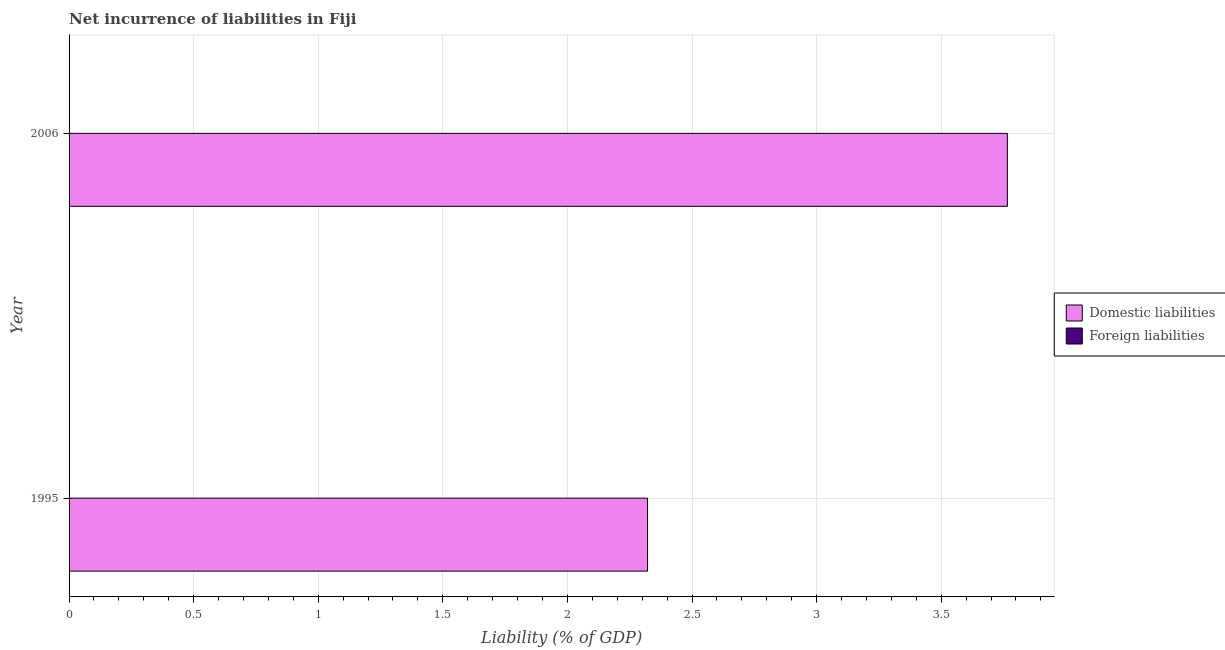Are the number of bars per tick equal to the number of legend labels?
Your answer should be compact. No. How many bars are there on the 2nd tick from the top?
Provide a succinct answer. 1. What is the label of the 1st group of bars from the top?
Your answer should be very brief. 2006. What is the incurrence of foreign liabilities in 2006?
Provide a short and direct response. 0. Across all years, what is the maximum incurrence of domestic liabilities?
Your answer should be very brief. 3.77. In which year was the incurrence of domestic liabilities maximum?
Your answer should be very brief. 2006. What is the difference between the incurrence of domestic liabilities in 1995 and that in 2006?
Keep it short and to the point. -1.44. What is the difference between the incurrence of foreign liabilities in 2006 and the incurrence of domestic liabilities in 1995?
Give a very brief answer. -2.32. What is the average incurrence of domestic liabilities per year?
Keep it short and to the point. 3.04. What is the ratio of the incurrence of domestic liabilities in 1995 to that in 2006?
Your response must be concise. 0.62. Is the incurrence of domestic liabilities in 1995 less than that in 2006?
Make the answer very short. Yes. In how many years, is the incurrence of domestic liabilities greater than the average incurrence of domestic liabilities taken over all years?
Your response must be concise. 1. How many bars are there?
Your answer should be very brief. 2. Are all the bars in the graph horizontal?
Your answer should be very brief. Yes. What is the difference between two consecutive major ticks on the X-axis?
Keep it short and to the point. 0.5. Does the graph contain any zero values?
Your response must be concise. Yes. Where does the legend appear in the graph?
Provide a succinct answer. Center right. What is the title of the graph?
Provide a short and direct response. Net incurrence of liabilities in Fiji. What is the label or title of the X-axis?
Keep it short and to the point. Liability (% of GDP). What is the label or title of the Y-axis?
Give a very brief answer. Year. What is the Liability (% of GDP) in Domestic liabilities in 1995?
Your response must be concise. 2.32. What is the Liability (% of GDP) of Foreign liabilities in 1995?
Keep it short and to the point. 0. What is the Liability (% of GDP) of Domestic liabilities in 2006?
Make the answer very short. 3.77. What is the Liability (% of GDP) of Foreign liabilities in 2006?
Ensure brevity in your answer.  0. Across all years, what is the maximum Liability (% of GDP) of Domestic liabilities?
Keep it short and to the point. 3.77. Across all years, what is the minimum Liability (% of GDP) in Domestic liabilities?
Keep it short and to the point. 2.32. What is the total Liability (% of GDP) of Domestic liabilities in the graph?
Your answer should be compact. 6.09. What is the total Liability (% of GDP) in Foreign liabilities in the graph?
Provide a succinct answer. 0. What is the difference between the Liability (% of GDP) in Domestic liabilities in 1995 and that in 2006?
Give a very brief answer. -1.44. What is the average Liability (% of GDP) of Domestic liabilities per year?
Make the answer very short. 3.04. What is the average Liability (% of GDP) of Foreign liabilities per year?
Provide a succinct answer. 0. What is the ratio of the Liability (% of GDP) in Domestic liabilities in 1995 to that in 2006?
Your response must be concise. 0.62. What is the difference between the highest and the second highest Liability (% of GDP) in Domestic liabilities?
Your answer should be compact. 1.44. What is the difference between the highest and the lowest Liability (% of GDP) in Domestic liabilities?
Provide a succinct answer. 1.44. 